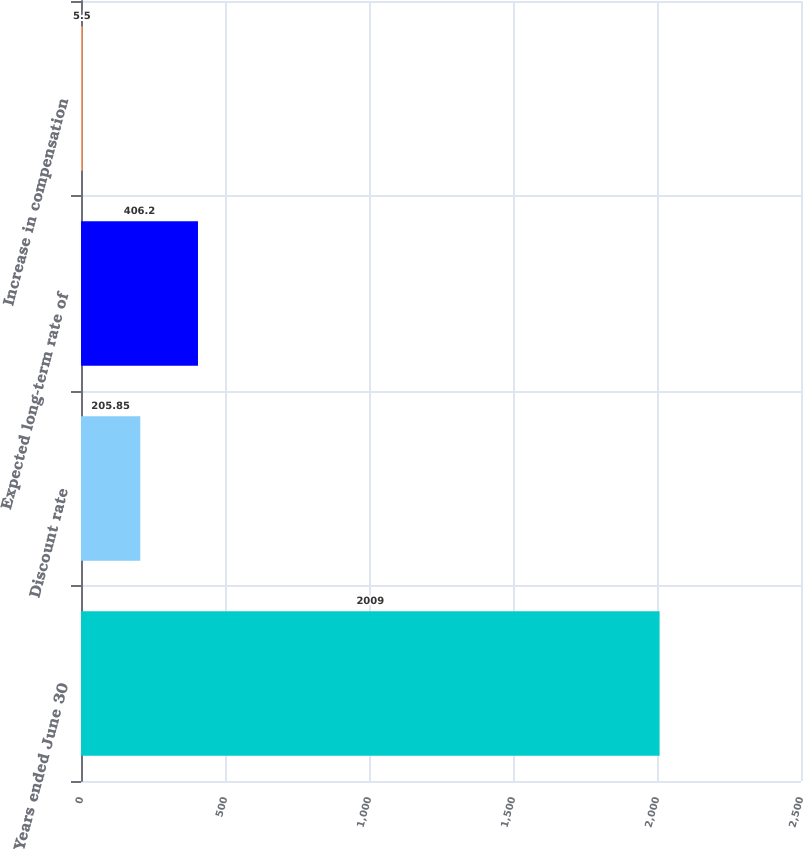<chart> <loc_0><loc_0><loc_500><loc_500><bar_chart><fcel>Years ended June 30<fcel>Discount rate<fcel>Expected long-term rate of<fcel>Increase in compensation<nl><fcel>2009<fcel>205.85<fcel>406.2<fcel>5.5<nl></chart> 